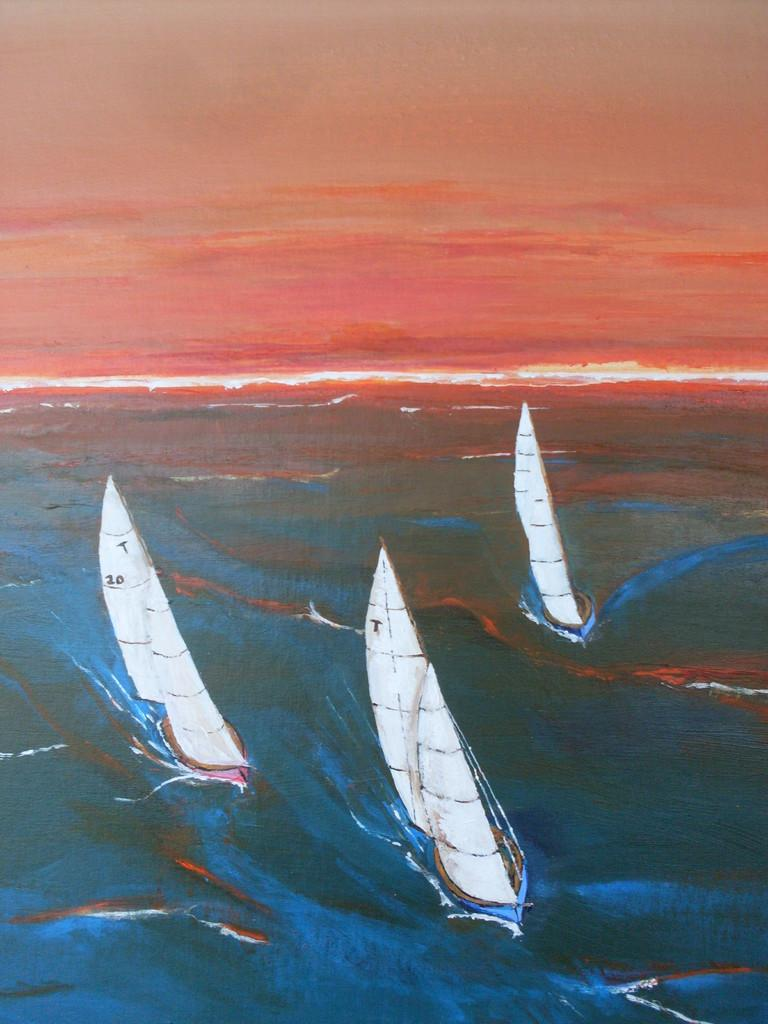<image>
Summarize the visual content of the image. Three white sail boats in a painting, two of which have the letter T on their sails. 